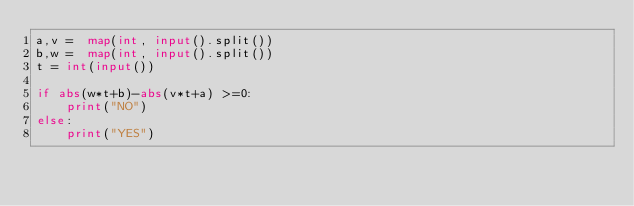Convert code to text. <code><loc_0><loc_0><loc_500><loc_500><_Python_>a,v =  map(int, input().split())
b,w =  map(int, input().split())
t = int(input())

if abs(w*t+b)-abs(v*t+a) >=0:
    print("NO")
else:
    print("YES")</code> 